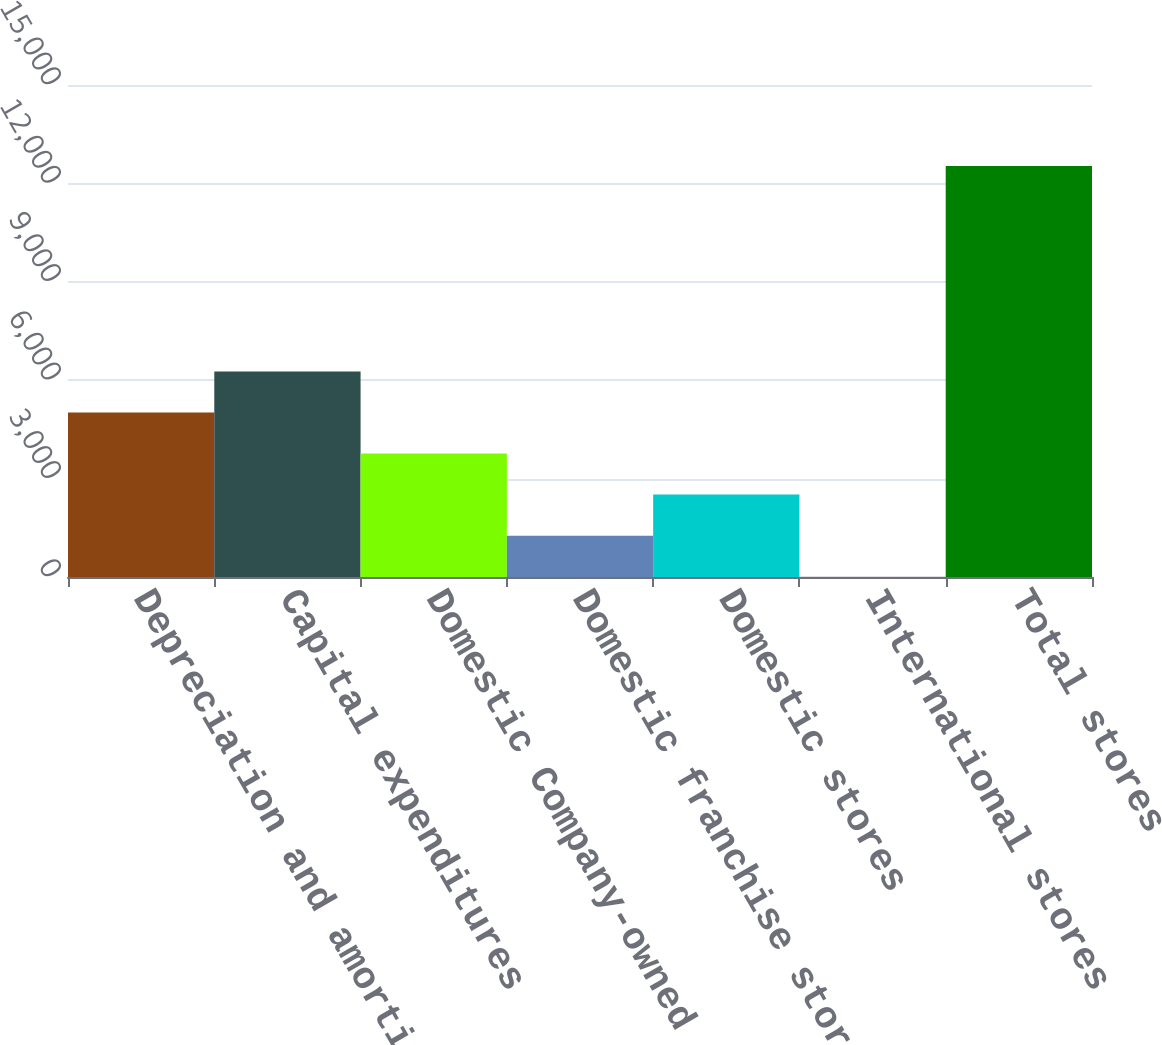<chart> <loc_0><loc_0><loc_500><loc_500><bar_chart><fcel>Depreciation and amortization<fcel>Capital expenditures<fcel>Domestic Company-owned stores<fcel>Domestic franchise stores<fcel>Domestic stores<fcel>International stores<fcel>Total stores<nl><fcel>5016.68<fcel>6268.9<fcel>3764.46<fcel>1260.02<fcel>2512.24<fcel>7.8<fcel>12530<nl></chart> 